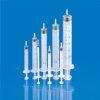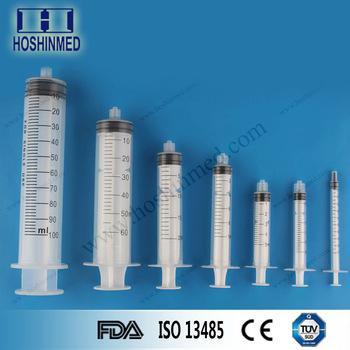The first image is the image on the left, the second image is the image on the right. Given the left and right images, does the statement "Right image shows syringes arranged big to small, with the biggest in volume on the left." hold true? Answer yes or no. Yes. The first image is the image on the left, the second image is the image on the right. Examine the images to the left and right. Is the description "One of the images has exactly 7 syringes." accurate? Answer yes or no. Yes. 